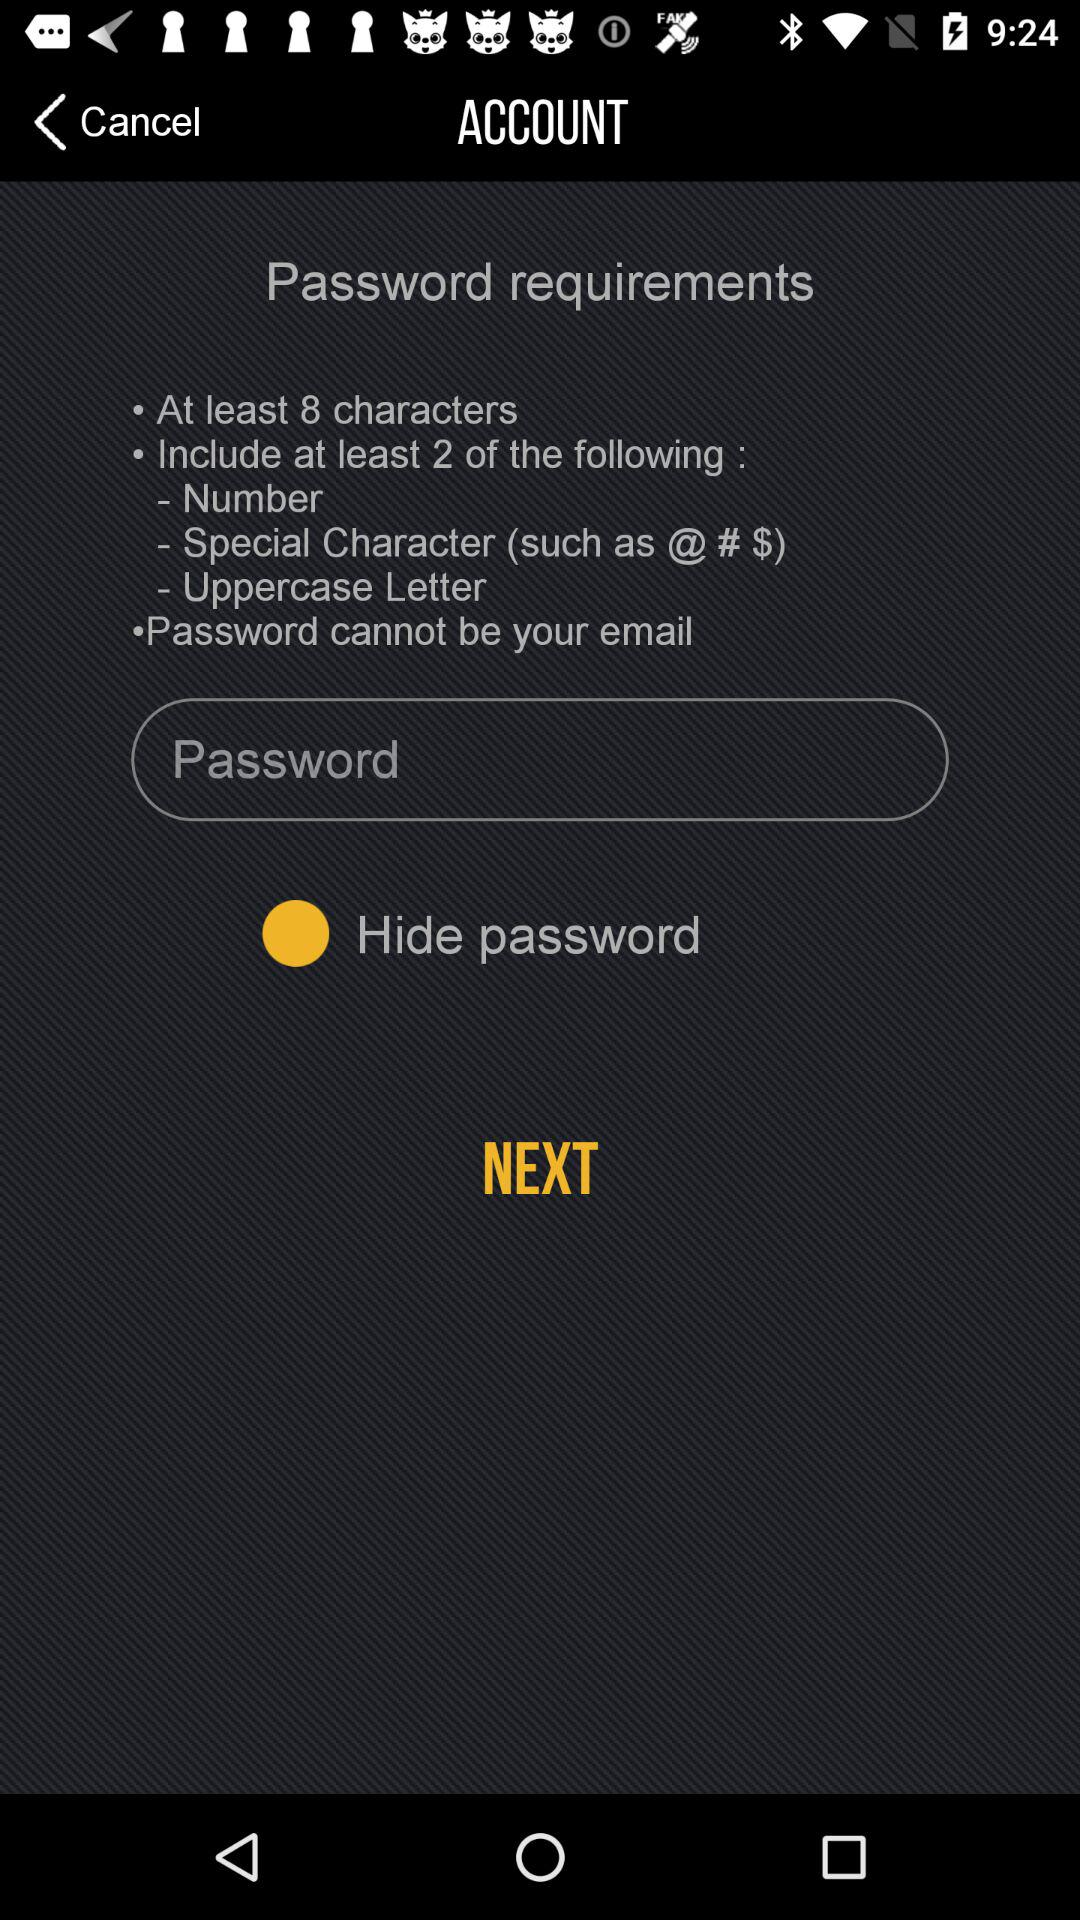What should not be a password? You should not use your email as a password. 